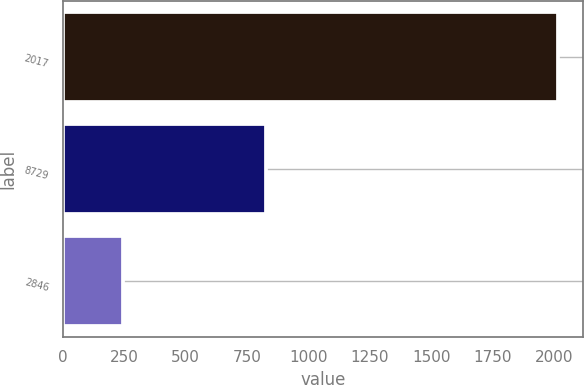Convert chart. <chart><loc_0><loc_0><loc_500><loc_500><bar_chart><fcel>2017<fcel>8729<fcel>2846<nl><fcel>2016<fcel>826.6<fcel>244.3<nl></chart> 